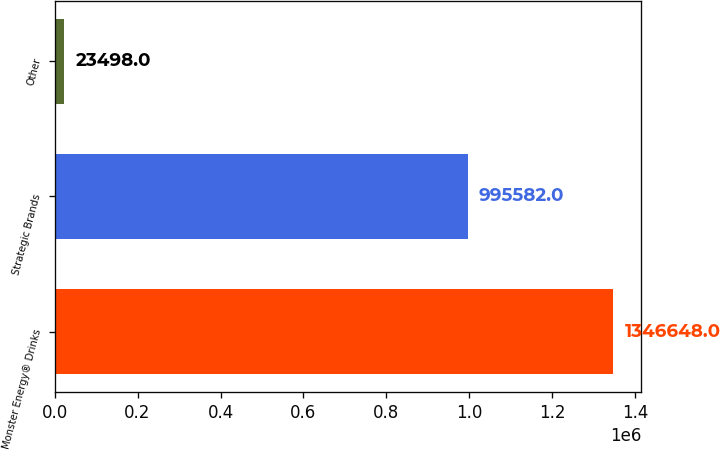Convert chart to OTSL. <chart><loc_0><loc_0><loc_500><loc_500><bar_chart><fcel>Monster Energy® Drinks<fcel>Strategic Brands<fcel>Other<nl><fcel>1.34665e+06<fcel>995582<fcel>23498<nl></chart> 